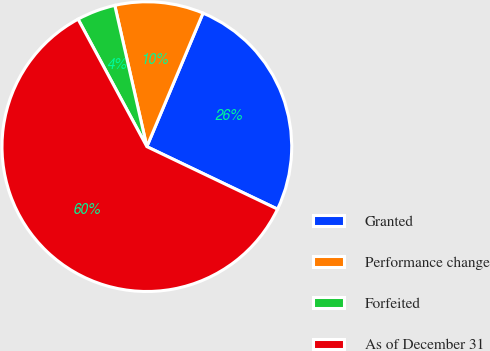Convert chart to OTSL. <chart><loc_0><loc_0><loc_500><loc_500><pie_chart><fcel>Granted<fcel>Performance change<fcel>Forfeited<fcel>As of December 31<nl><fcel>25.76%<fcel>9.89%<fcel>4.32%<fcel>60.02%<nl></chart> 